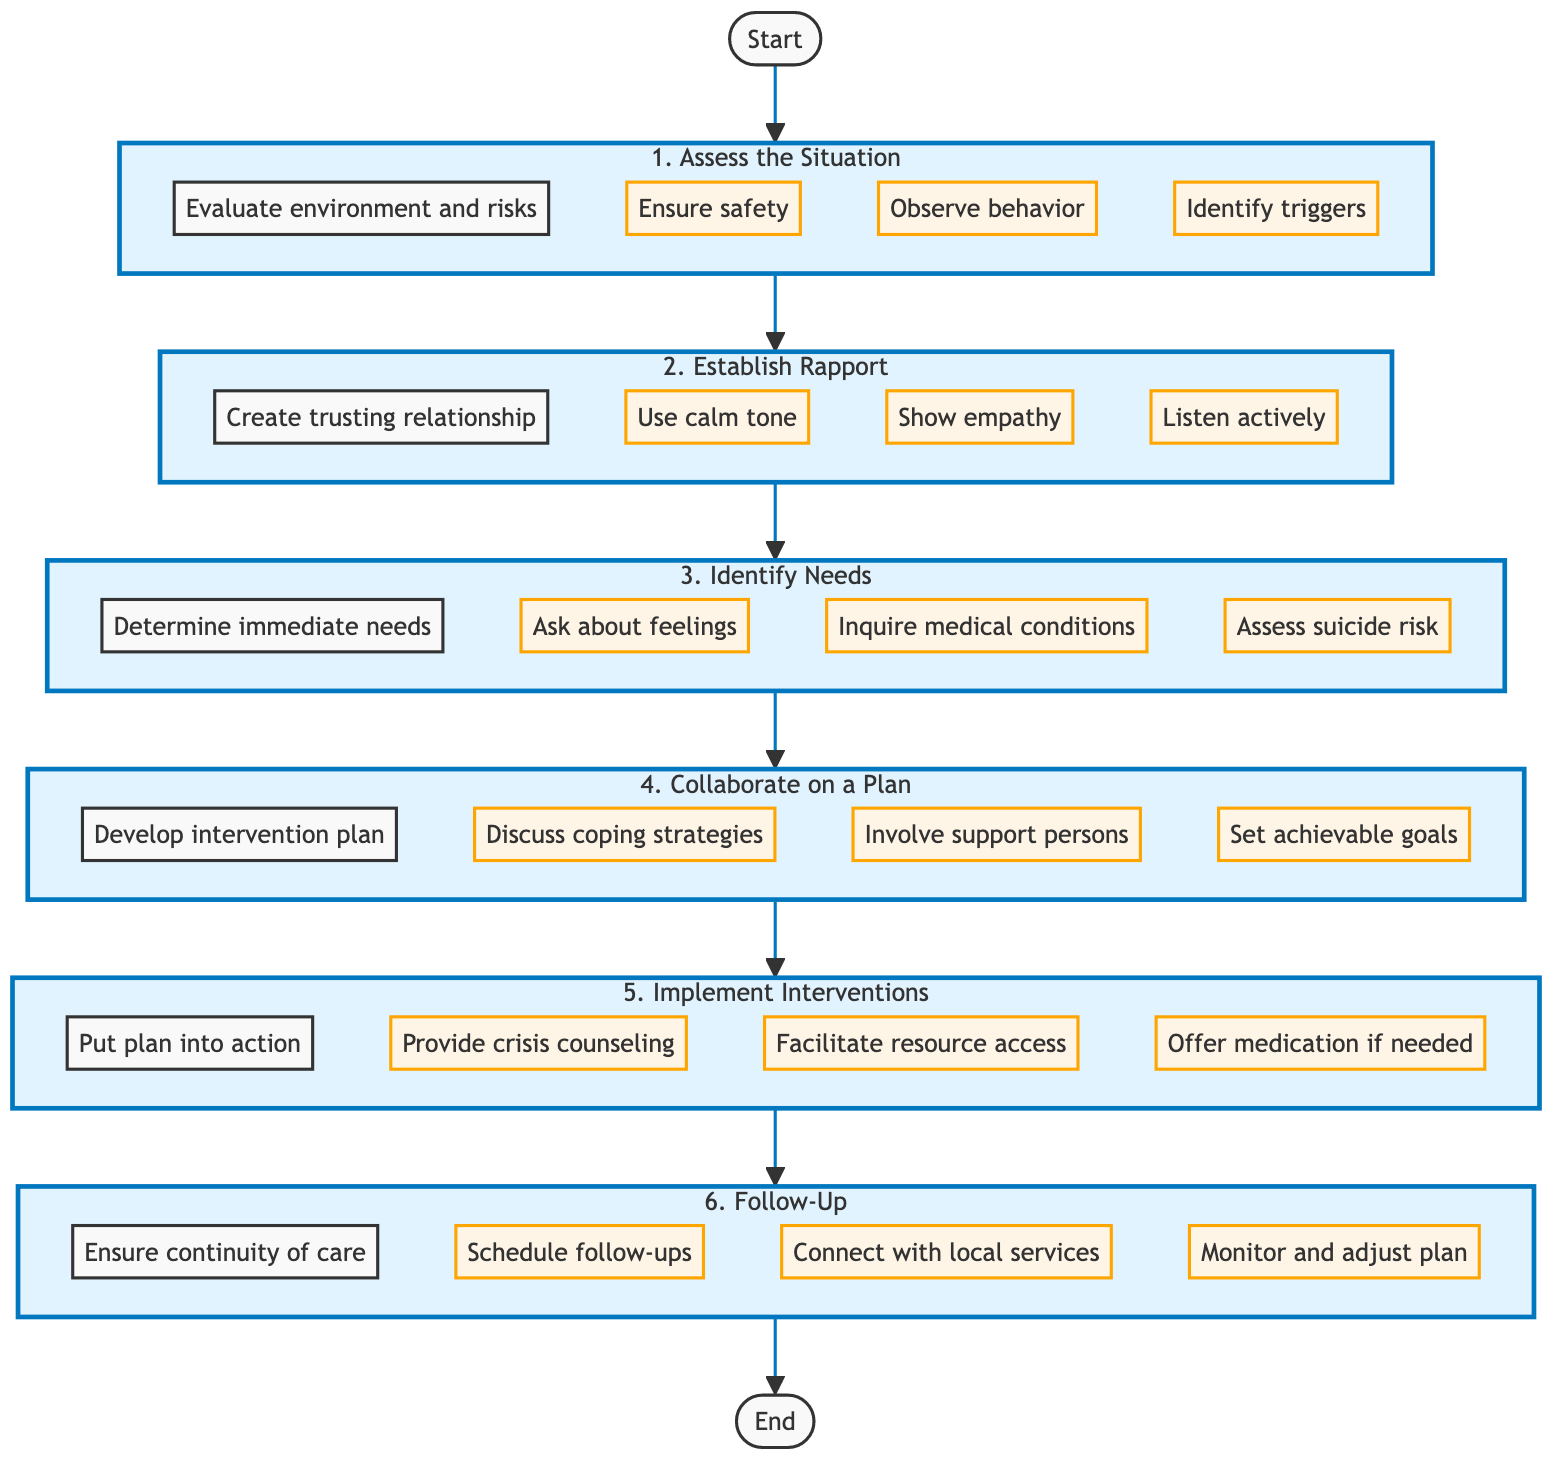What is the first step in the crisis intervention process? The first step is "Assess the Situation," which evaluates the environment and identifies immediate risks.
Answer: Assess the Situation How many main steps are there in the crisis intervention flowchart? The flowchart contains six main steps that outline the intervention process sequentially.
Answer: Six What three actions are included in the "Establish Rapport" step? The actions are "Use calm tone," "Show empathy," and "Listen actively."
Answer: Use calm tone, Show empathy, Listen actively What do you do in step three after identifying needs? In step four, you "Collaborate on a Plan" to devise an intervention plan based on the identified needs.
Answer: Collaborate on a Plan What is the last action in the crisis intervention process? The last action in the follow-up step is to "Monitor progress and adjust the plan as needed."
Answer: Monitor progress and adjust the plan as needed Which step involves discussing coping strategies? The step that involves discussing coping strategies is "Collaborate on a Plan," specifically in action D1.
Answer: Collaborate on a Plan What is the relationship between Step 4 and Step 5? Step 4 involves collaboration on a plan, which is then put into action in Step 5.
Answer: Collaboration to Implementation Which step precedes "Implement Interventions"? The step that comes before "Implement Interventions" is "Collaborate on a Plan."
Answer: Collaborate on a Plan What is required after the implementation of the intervention in step five? Follow-Up is required to ensure continuity of care after implementing the intervention.
Answer: Follow-Up 